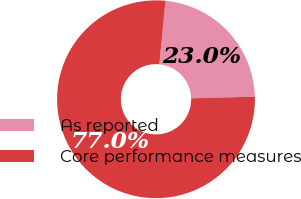<chart> <loc_0><loc_0><loc_500><loc_500><pie_chart><fcel>As reported<fcel>Core performance measures<nl><fcel>23.04%<fcel>76.96%<nl></chart> 